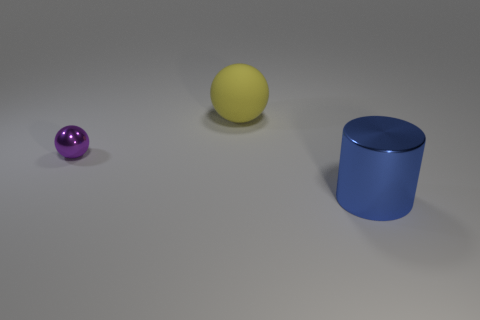Add 2 big metallic blocks. How many objects exist? 5 Subtract all cylinders. How many objects are left? 2 Add 3 small brown matte things. How many small brown matte things exist? 3 Subtract 0 gray cylinders. How many objects are left? 3 Subtract all large metal cylinders. Subtract all small red metal cylinders. How many objects are left? 2 Add 2 large shiny cylinders. How many large shiny cylinders are left? 3 